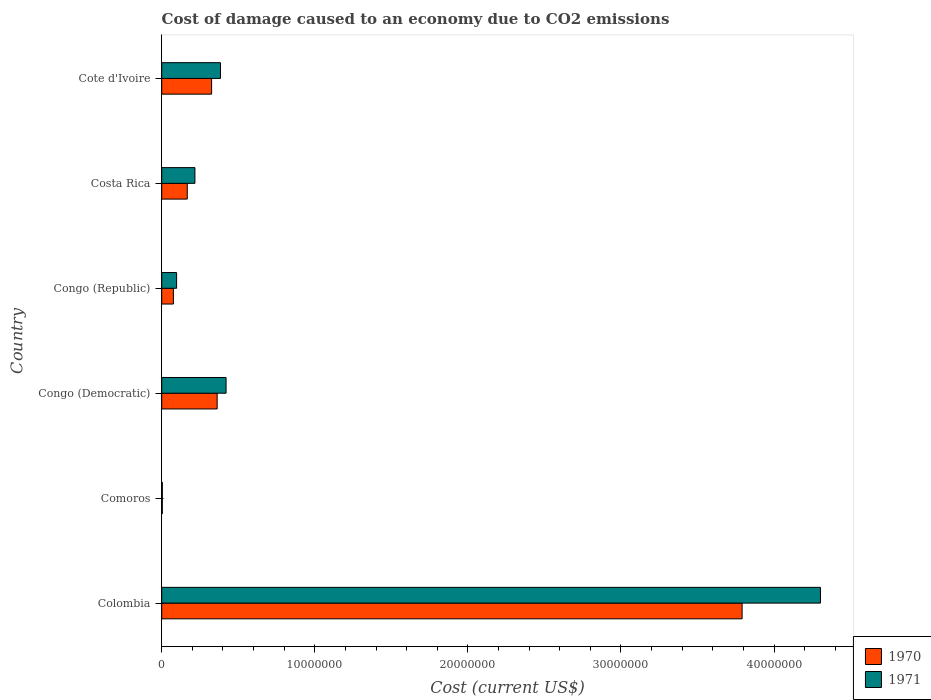How many different coloured bars are there?
Give a very brief answer. 2. Are the number of bars on each tick of the Y-axis equal?
Give a very brief answer. Yes. What is the label of the 5th group of bars from the top?
Your answer should be very brief. Comoros. In how many cases, is the number of bars for a given country not equal to the number of legend labels?
Ensure brevity in your answer.  0. What is the cost of damage caused due to CO2 emissisons in 1970 in Colombia?
Your answer should be compact. 3.79e+07. Across all countries, what is the maximum cost of damage caused due to CO2 emissisons in 1970?
Give a very brief answer. 3.79e+07. Across all countries, what is the minimum cost of damage caused due to CO2 emissisons in 1971?
Keep it short and to the point. 4.16e+04. In which country was the cost of damage caused due to CO2 emissisons in 1970 minimum?
Offer a very short reply. Comoros. What is the total cost of damage caused due to CO2 emissisons in 1971 in the graph?
Ensure brevity in your answer.  5.43e+07. What is the difference between the cost of damage caused due to CO2 emissisons in 1971 in Congo (Democratic) and that in Cote d'Ivoire?
Make the answer very short. 3.64e+05. What is the difference between the cost of damage caused due to CO2 emissisons in 1970 in Costa Rica and the cost of damage caused due to CO2 emissisons in 1971 in Comoros?
Your response must be concise. 1.63e+06. What is the average cost of damage caused due to CO2 emissisons in 1971 per country?
Your answer should be compact. 9.04e+06. What is the difference between the cost of damage caused due to CO2 emissisons in 1971 and cost of damage caused due to CO2 emissisons in 1970 in Congo (Democratic)?
Give a very brief answer. 5.82e+05. In how many countries, is the cost of damage caused due to CO2 emissisons in 1970 greater than 28000000 US$?
Your answer should be compact. 1. What is the ratio of the cost of damage caused due to CO2 emissisons in 1971 in Comoros to that in Congo (Democratic)?
Make the answer very short. 0.01. Is the cost of damage caused due to CO2 emissisons in 1971 in Colombia less than that in Cote d'Ivoire?
Offer a terse response. No. Is the difference between the cost of damage caused due to CO2 emissisons in 1971 in Colombia and Cote d'Ivoire greater than the difference between the cost of damage caused due to CO2 emissisons in 1970 in Colombia and Cote d'Ivoire?
Provide a succinct answer. Yes. What is the difference between the highest and the second highest cost of damage caused due to CO2 emissisons in 1971?
Offer a very short reply. 3.88e+07. What is the difference between the highest and the lowest cost of damage caused due to CO2 emissisons in 1971?
Provide a succinct answer. 4.30e+07. In how many countries, is the cost of damage caused due to CO2 emissisons in 1970 greater than the average cost of damage caused due to CO2 emissisons in 1970 taken over all countries?
Your answer should be compact. 1. Is the sum of the cost of damage caused due to CO2 emissisons in 1971 in Congo (Republic) and Cote d'Ivoire greater than the maximum cost of damage caused due to CO2 emissisons in 1970 across all countries?
Make the answer very short. No. How many bars are there?
Keep it short and to the point. 12. Are all the bars in the graph horizontal?
Offer a very short reply. Yes. How many countries are there in the graph?
Offer a terse response. 6. What is the difference between two consecutive major ticks on the X-axis?
Offer a terse response. 1.00e+07. Does the graph contain any zero values?
Provide a short and direct response. No. Where does the legend appear in the graph?
Provide a short and direct response. Bottom right. What is the title of the graph?
Provide a short and direct response. Cost of damage caused to an economy due to CO2 emissions. What is the label or title of the X-axis?
Your response must be concise. Cost (current US$). What is the label or title of the Y-axis?
Provide a short and direct response. Country. What is the Cost (current US$) of 1970 in Colombia?
Provide a succinct answer. 3.79e+07. What is the Cost (current US$) in 1971 in Colombia?
Provide a short and direct response. 4.30e+07. What is the Cost (current US$) in 1970 in Comoros?
Offer a very short reply. 3.92e+04. What is the Cost (current US$) in 1971 in Comoros?
Your answer should be very brief. 4.16e+04. What is the Cost (current US$) of 1970 in Congo (Democratic)?
Provide a short and direct response. 3.62e+06. What is the Cost (current US$) in 1971 in Congo (Democratic)?
Provide a short and direct response. 4.20e+06. What is the Cost (current US$) of 1970 in Congo (Republic)?
Your response must be concise. 7.64e+05. What is the Cost (current US$) of 1971 in Congo (Republic)?
Offer a terse response. 9.73e+05. What is the Cost (current US$) of 1970 in Costa Rica?
Offer a terse response. 1.67e+06. What is the Cost (current US$) of 1971 in Costa Rica?
Make the answer very short. 2.17e+06. What is the Cost (current US$) in 1970 in Cote d'Ivoire?
Keep it short and to the point. 3.26e+06. What is the Cost (current US$) of 1971 in Cote d'Ivoire?
Provide a short and direct response. 3.84e+06. Across all countries, what is the maximum Cost (current US$) in 1970?
Your answer should be very brief. 3.79e+07. Across all countries, what is the maximum Cost (current US$) of 1971?
Provide a short and direct response. 4.30e+07. Across all countries, what is the minimum Cost (current US$) in 1970?
Give a very brief answer. 3.92e+04. Across all countries, what is the minimum Cost (current US$) of 1971?
Keep it short and to the point. 4.16e+04. What is the total Cost (current US$) of 1970 in the graph?
Ensure brevity in your answer.  4.73e+07. What is the total Cost (current US$) of 1971 in the graph?
Keep it short and to the point. 5.43e+07. What is the difference between the Cost (current US$) in 1970 in Colombia and that in Comoros?
Give a very brief answer. 3.79e+07. What is the difference between the Cost (current US$) in 1971 in Colombia and that in Comoros?
Your response must be concise. 4.30e+07. What is the difference between the Cost (current US$) of 1970 in Colombia and that in Congo (Democratic)?
Your answer should be compact. 3.43e+07. What is the difference between the Cost (current US$) of 1971 in Colombia and that in Congo (Democratic)?
Ensure brevity in your answer.  3.88e+07. What is the difference between the Cost (current US$) in 1970 in Colombia and that in Congo (Republic)?
Give a very brief answer. 3.72e+07. What is the difference between the Cost (current US$) of 1971 in Colombia and that in Congo (Republic)?
Provide a succinct answer. 4.21e+07. What is the difference between the Cost (current US$) of 1970 in Colombia and that in Costa Rica?
Your answer should be compact. 3.62e+07. What is the difference between the Cost (current US$) of 1971 in Colombia and that in Costa Rica?
Keep it short and to the point. 4.09e+07. What is the difference between the Cost (current US$) of 1970 in Colombia and that in Cote d'Ivoire?
Give a very brief answer. 3.47e+07. What is the difference between the Cost (current US$) in 1971 in Colombia and that in Cote d'Ivoire?
Offer a very short reply. 3.92e+07. What is the difference between the Cost (current US$) in 1970 in Comoros and that in Congo (Democratic)?
Your response must be concise. -3.58e+06. What is the difference between the Cost (current US$) in 1971 in Comoros and that in Congo (Democratic)?
Provide a short and direct response. -4.16e+06. What is the difference between the Cost (current US$) in 1970 in Comoros and that in Congo (Republic)?
Give a very brief answer. -7.24e+05. What is the difference between the Cost (current US$) of 1971 in Comoros and that in Congo (Republic)?
Your answer should be compact. -9.31e+05. What is the difference between the Cost (current US$) in 1970 in Comoros and that in Costa Rica?
Keep it short and to the point. -1.63e+06. What is the difference between the Cost (current US$) of 1971 in Comoros and that in Costa Rica?
Provide a succinct answer. -2.13e+06. What is the difference between the Cost (current US$) in 1970 in Comoros and that in Cote d'Ivoire?
Give a very brief answer. -3.22e+06. What is the difference between the Cost (current US$) in 1971 in Comoros and that in Cote d'Ivoire?
Offer a terse response. -3.80e+06. What is the difference between the Cost (current US$) in 1970 in Congo (Democratic) and that in Congo (Republic)?
Make the answer very short. 2.86e+06. What is the difference between the Cost (current US$) in 1971 in Congo (Democratic) and that in Congo (Republic)?
Keep it short and to the point. 3.23e+06. What is the difference between the Cost (current US$) in 1970 in Congo (Democratic) and that in Costa Rica?
Your answer should be compact. 1.95e+06. What is the difference between the Cost (current US$) in 1971 in Congo (Democratic) and that in Costa Rica?
Give a very brief answer. 2.03e+06. What is the difference between the Cost (current US$) in 1970 in Congo (Democratic) and that in Cote d'Ivoire?
Provide a succinct answer. 3.62e+05. What is the difference between the Cost (current US$) in 1971 in Congo (Democratic) and that in Cote d'Ivoire?
Your response must be concise. 3.64e+05. What is the difference between the Cost (current US$) of 1970 in Congo (Republic) and that in Costa Rica?
Offer a terse response. -9.06e+05. What is the difference between the Cost (current US$) of 1971 in Congo (Republic) and that in Costa Rica?
Your answer should be very brief. -1.20e+06. What is the difference between the Cost (current US$) of 1970 in Congo (Republic) and that in Cote d'Ivoire?
Ensure brevity in your answer.  -2.50e+06. What is the difference between the Cost (current US$) in 1971 in Congo (Republic) and that in Cote d'Ivoire?
Keep it short and to the point. -2.87e+06. What is the difference between the Cost (current US$) in 1970 in Costa Rica and that in Cote d'Ivoire?
Make the answer very short. -1.59e+06. What is the difference between the Cost (current US$) of 1971 in Costa Rica and that in Cote d'Ivoire?
Offer a terse response. -1.67e+06. What is the difference between the Cost (current US$) of 1970 in Colombia and the Cost (current US$) of 1971 in Comoros?
Provide a short and direct response. 3.79e+07. What is the difference between the Cost (current US$) of 1970 in Colombia and the Cost (current US$) of 1971 in Congo (Democratic)?
Provide a short and direct response. 3.37e+07. What is the difference between the Cost (current US$) in 1970 in Colombia and the Cost (current US$) in 1971 in Congo (Republic)?
Make the answer very short. 3.69e+07. What is the difference between the Cost (current US$) of 1970 in Colombia and the Cost (current US$) of 1971 in Costa Rica?
Provide a succinct answer. 3.57e+07. What is the difference between the Cost (current US$) of 1970 in Colombia and the Cost (current US$) of 1971 in Cote d'Ivoire?
Offer a terse response. 3.41e+07. What is the difference between the Cost (current US$) in 1970 in Comoros and the Cost (current US$) in 1971 in Congo (Democratic)?
Your answer should be compact. -4.17e+06. What is the difference between the Cost (current US$) of 1970 in Comoros and the Cost (current US$) of 1971 in Congo (Republic)?
Your answer should be very brief. -9.34e+05. What is the difference between the Cost (current US$) in 1970 in Comoros and the Cost (current US$) in 1971 in Costa Rica?
Give a very brief answer. -2.13e+06. What is the difference between the Cost (current US$) in 1970 in Comoros and the Cost (current US$) in 1971 in Cote d'Ivoire?
Your answer should be very brief. -3.80e+06. What is the difference between the Cost (current US$) of 1970 in Congo (Democratic) and the Cost (current US$) of 1971 in Congo (Republic)?
Your answer should be compact. 2.65e+06. What is the difference between the Cost (current US$) in 1970 in Congo (Democratic) and the Cost (current US$) in 1971 in Costa Rica?
Offer a terse response. 1.45e+06. What is the difference between the Cost (current US$) of 1970 in Congo (Democratic) and the Cost (current US$) of 1971 in Cote d'Ivoire?
Your answer should be very brief. -2.18e+05. What is the difference between the Cost (current US$) of 1970 in Congo (Republic) and the Cost (current US$) of 1971 in Costa Rica?
Make the answer very short. -1.41e+06. What is the difference between the Cost (current US$) in 1970 in Congo (Republic) and the Cost (current US$) in 1971 in Cote d'Ivoire?
Give a very brief answer. -3.08e+06. What is the difference between the Cost (current US$) of 1970 in Costa Rica and the Cost (current US$) of 1971 in Cote d'Ivoire?
Keep it short and to the point. -2.17e+06. What is the average Cost (current US$) of 1970 per country?
Offer a terse response. 7.88e+06. What is the average Cost (current US$) in 1971 per country?
Your response must be concise. 9.04e+06. What is the difference between the Cost (current US$) of 1970 and Cost (current US$) of 1971 in Colombia?
Provide a succinct answer. -5.12e+06. What is the difference between the Cost (current US$) of 1970 and Cost (current US$) of 1971 in Comoros?
Give a very brief answer. -2471.88. What is the difference between the Cost (current US$) in 1970 and Cost (current US$) in 1971 in Congo (Democratic)?
Offer a terse response. -5.82e+05. What is the difference between the Cost (current US$) in 1970 and Cost (current US$) in 1971 in Congo (Republic)?
Your answer should be compact. -2.10e+05. What is the difference between the Cost (current US$) in 1970 and Cost (current US$) in 1971 in Costa Rica?
Provide a short and direct response. -5.01e+05. What is the difference between the Cost (current US$) in 1970 and Cost (current US$) in 1971 in Cote d'Ivoire?
Provide a short and direct response. -5.80e+05. What is the ratio of the Cost (current US$) of 1970 in Colombia to that in Comoros?
Your response must be concise. 968.25. What is the ratio of the Cost (current US$) of 1971 in Colombia to that in Comoros?
Give a very brief answer. 1033.75. What is the ratio of the Cost (current US$) in 1970 in Colombia to that in Congo (Democratic)?
Make the answer very short. 10.47. What is the ratio of the Cost (current US$) of 1971 in Colombia to that in Congo (Democratic)?
Offer a terse response. 10.24. What is the ratio of the Cost (current US$) in 1970 in Colombia to that in Congo (Republic)?
Give a very brief answer. 49.65. What is the ratio of the Cost (current US$) in 1971 in Colombia to that in Congo (Republic)?
Your answer should be compact. 44.22. What is the ratio of the Cost (current US$) of 1970 in Colombia to that in Costa Rica?
Your response must be concise. 22.72. What is the ratio of the Cost (current US$) in 1971 in Colombia to that in Costa Rica?
Your answer should be very brief. 19.83. What is the ratio of the Cost (current US$) in 1970 in Colombia to that in Cote d'Ivoire?
Your answer should be compact. 11.63. What is the ratio of the Cost (current US$) of 1971 in Colombia to that in Cote d'Ivoire?
Give a very brief answer. 11.21. What is the ratio of the Cost (current US$) in 1970 in Comoros to that in Congo (Democratic)?
Ensure brevity in your answer.  0.01. What is the ratio of the Cost (current US$) of 1971 in Comoros to that in Congo (Democratic)?
Provide a succinct answer. 0.01. What is the ratio of the Cost (current US$) in 1970 in Comoros to that in Congo (Republic)?
Give a very brief answer. 0.05. What is the ratio of the Cost (current US$) in 1971 in Comoros to that in Congo (Republic)?
Ensure brevity in your answer.  0.04. What is the ratio of the Cost (current US$) of 1970 in Comoros to that in Costa Rica?
Ensure brevity in your answer.  0.02. What is the ratio of the Cost (current US$) of 1971 in Comoros to that in Costa Rica?
Your answer should be very brief. 0.02. What is the ratio of the Cost (current US$) of 1970 in Comoros to that in Cote d'Ivoire?
Provide a short and direct response. 0.01. What is the ratio of the Cost (current US$) in 1971 in Comoros to that in Cote d'Ivoire?
Make the answer very short. 0.01. What is the ratio of the Cost (current US$) of 1970 in Congo (Democratic) to that in Congo (Republic)?
Provide a short and direct response. 4.74. What is the ratio of the Cost (current US$) of 1971 in Congo (Democratic) to that in Congo (Republic)?
Provide a short and direct response. 4.32. What is the ratio of the Cost (current US$) in 1970 in Congo (Democratic) to that in Costa Rica?
Give a very brief answer. 2.17. What is the ratio of the Cost (current US$) of 1971 in Congo (Democratic) to that in Costa Rica?
Make the answer very short. 1.94. What is the ratio of the Cost (current US$) in 1971 in Congo (Democratic) to that in Cote d'Ivoire?
Provide a short and direct response. 1.09. What is the ratio of the Cost (current US$) of 1970 in Congo (Republic) to that in Costa Rica?
Offer a very short reply. 0.46. What is the ratio of the Cost (current US$) of 1971 in Congo (Republic) to that in Costa Rica?
Offer a very short reply. 0.45. What is the ratio of the Cost (current US$) in 1970 in Congo (Republic) to that in Cote d'Ivoire?
Your response must be concise. 0.23. What is the ratio of the Cost (current US$) in 1971 in Congo (Republic) to that in Cote d'Ivoire?
Keep it short and to the point. 0.25. What is the ratio of the Cost (current US$) in 1970 in Costa Rica to that in Cote d'Ivoire?
Offer a terse response. 0.51. What is the ratio of the Cost (current US$) in 1971 in Costa Rica to that in Cote d'Ivoire?
Your answer should be very brief. 0.56. What is the difference between the highest and the second highest Cost (current US$) in 1970?
Provide a succinct answer. 3.43e+07. What is the difference between the highest and the second highest Cost (current US$) of 1971?
Your response must be concise. 3.88e+07. What is the difference between the highest and the lowest Cost (current US$) in 1970?
Keep it short and to the point. 3.79e+07. What is the difference between the highest and the lowest Cost (current US$) in 1971?
Offer a terse response. 4.30e+07. 